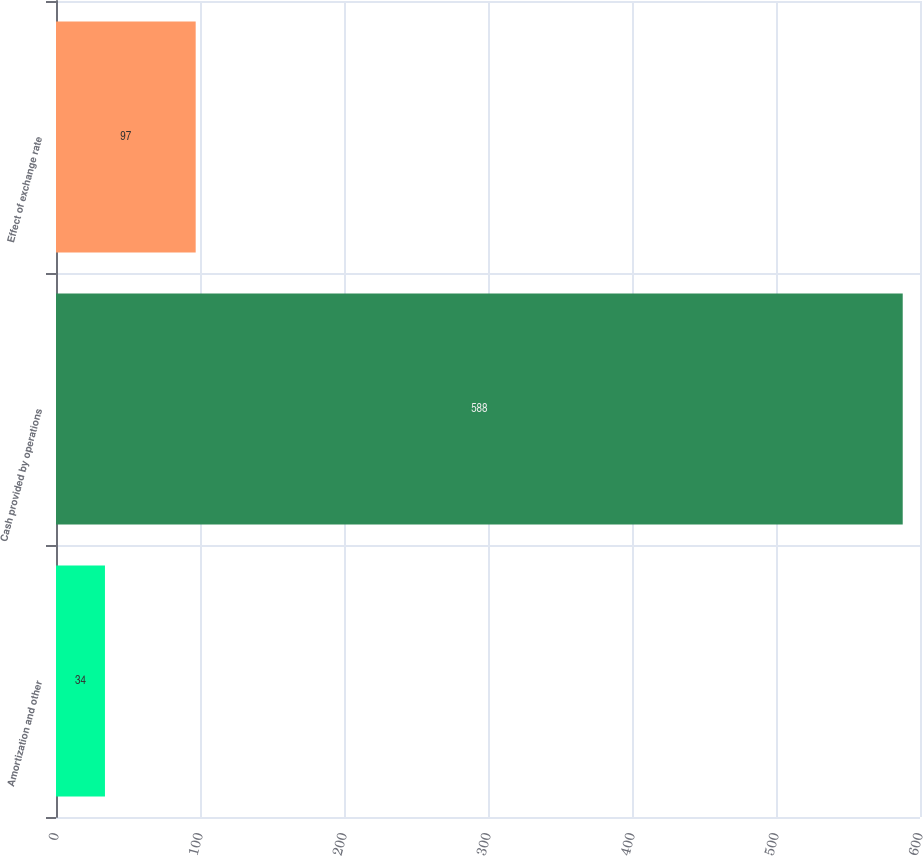Convert chart to OTSL. <chart><loc_0><loc_0><loc_500><loc_500><bar_chart><fcel>Amortization and other<fcel>Cash provided by operations<fcel>Effect of exchange rate<nl><fcel>34<fcel>588<fcel>97<nl></chart> 